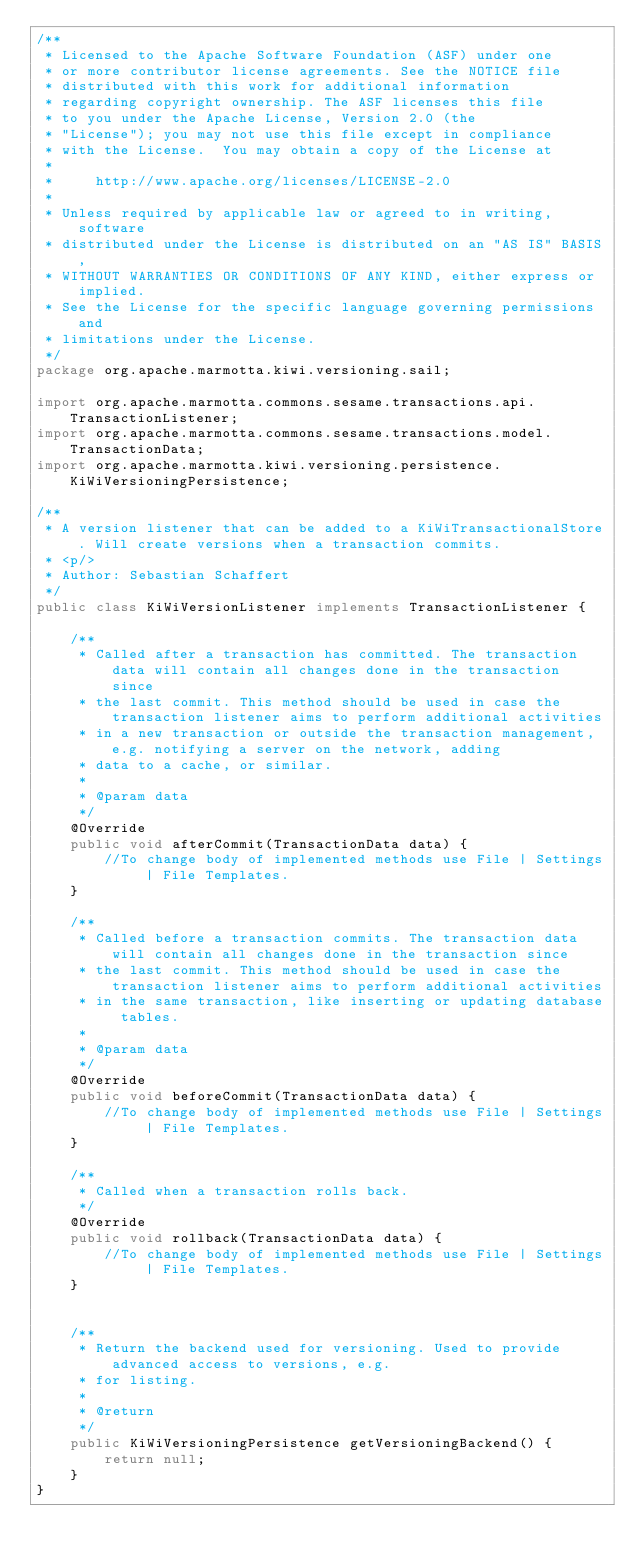<code> <loc_0><loc_0><loc_500><loc_500><_Java_>/**
 * Licensed to the Apache Software Foundation (ASF) under one
 * or more contributor license agreements. See the NOTICE file
 * distributed with this work for additional information
 * regarding copyright ownership. The ASF licenses this file
 * to you under the Apache License, Version 2.0 (the
 * "License"); you may not use this file except in compliance
 * with the License.  You may obtain a copy of the License at
 *
 *     http://www.apache.org/licenses/LICENSE-2.0
 *
 * Unless required by applicable law or agreed to in writing, software
 * distributed under the License is distributed on an "AS IS" BASIS,
 * WITHOUT WARRANTIES OR CONDITIONS OF ANY KIND, either express or implied.
 * See the License for the specific language governing permissions and
 * limitations under the License.
 */
package org.apache.marmotta.kiwi.versioning.sail;

import org.apache.marmotta.commons.sesame.transactions.api.TransactionListener;
import org.apache.marmotta.commons.sesame.transactions.model.TransactionData;
import org.apache.marmotta.kiwi.versioning.persistence.KiWiVersioningPersistence;

/**
 * A version listener that can be added to a KiWiTransactionalStore. Will create versions when a transaction commits.
 * <p/>
 * Author: Sebastian Schaffert
 */
public class KiWiVersionListener implements TransactionListener {

    /**
     * Called after a transaction has committed. The transaction data will contain all changes done in the transaction since
     * the last commit. This method should be used in case the transaction listener aims to perform additional activities
     * in a new transaction or outside the transaction management, e.g. notifying a server on the network, adding
     * data to a cache, or similar.
     *
     * @param data
     */
    @Override
    public void afterCommit(TransactionData data) {
        //To change body of implemented methods use File | Settings | File Templates.
    }

    /**
     * Called before a transaction commits. The transaction data will contain all changes done in the transaction since
     * the last commit. This method should be used in case the transaction listener aims to perform additional activities
     * in the same transaction, like inserting or updating database tables.
     *
     * @param data
     */
    @Override
    public void beforeCommit(TransactionData data) {
        //To change body of implemented methods use File | Settings | File Templates.
    }

    /**
     * Called when a transaction rolls back.
     */
    @Override
    public void rollback(TransactionData data) {
        //To change body of implemented methods use File | Settings | File Templates.
    }


    /**
     * Return the backend used for versioning. Used to provide advanced access to versions, e.g.
     * for listing.
     *
     * @return
     */
    public KiWiVersioningPersistence getVersioningBackend() {
        return null;
    }
}
</code> 